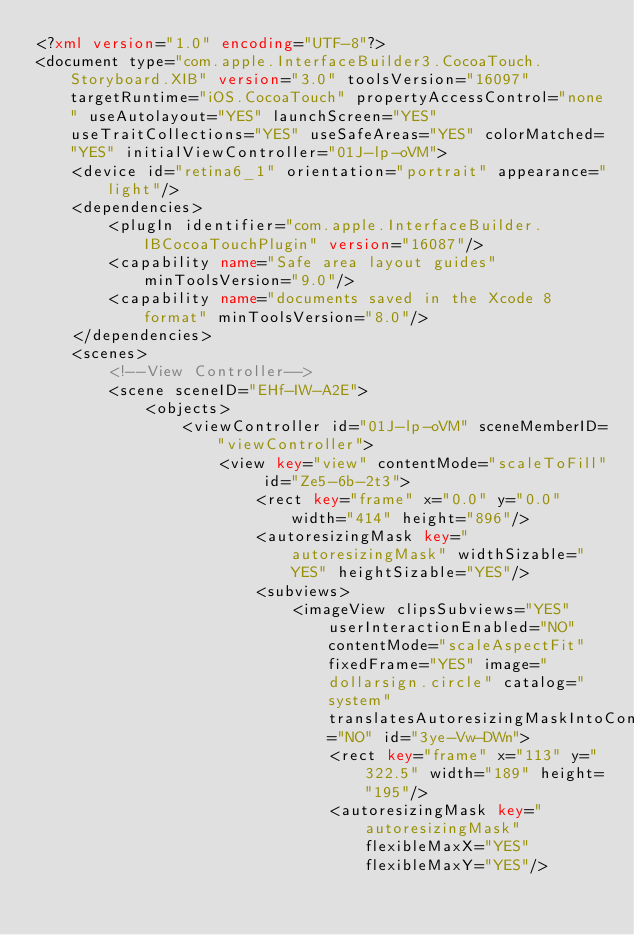<code> <loc_0><loc_0><loc_500><loc_500><_XML_><?xml version="1.0" encoding="UTF-8"?>
<document type="com.apple.InterfaceBuilder3.CocoaTouch.Storyboard.XIB" version="3.0" toolsVersion="16097" targetRuntime="iOS.CocoaTouch" propertyAccessControl="none" useAutolayout="YES" launchScreen="YES" useTraitCollections="YES" useSafeAreas="YES" colorMatched="YES" initialViewController="01J-lp-oVM">
    <device id="retina6_1" orientation="portrait" appearance="light"/>
    <dependencies>
        <plugIn identifier="com.apple.InterfaceBuilder.IBCocoaTouchPlugin" version="16087"/>
        <capability name="Safe area layout guides" minToolsVersion="9.0"/>
        <capability name="documents saved in the Xcode 8 format" minToolsVersion="8.0"/>
    </dependencies>
    <scenes>
        <!--View Controller-->
        <scene sceneID="EHf-IW-A2E">
            <objects>
                <viewController id="01J-lp-oVM" sceneMemberID="viewController">
                    <view key="view" contentMode="scaleToFill" id="Ze5-6b-2t3">
                        <rect key="frame" x="0.0" y="0.0" width="414" height="896"/>
                        <autoresizingMask key="autoresizingMask" widthSizable="YES" heightSizable="YES"/>
                        <subviews>
                            <imageView clipsSubviews="YES" userInteractionEnabled="NO" contentMode="scaleAspectFit" fixedFrame="YES" image="dollarsign.circle" catalog="system" translatesAutoresizingMaskIntoConstraints="NO" id="3ye-Vw-DWn">
                                <rect key="frame" x="113" y="322.5" width="189" height="195"/>
                                <autoresizingMask key="autoresizingMask" flexibleMaxX="YES" flexibleMaxY="YES"/></code> 